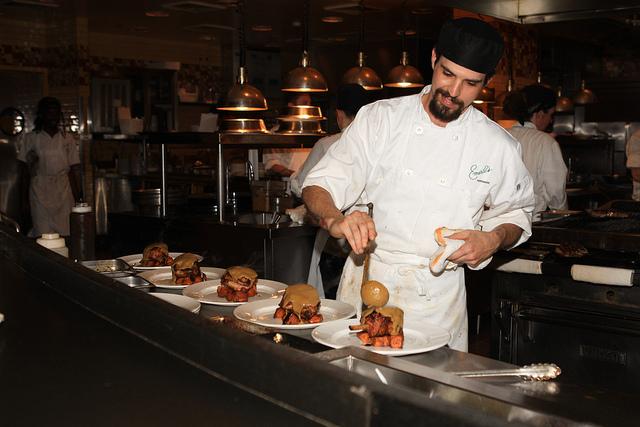What are the people making?
Be succinct. Dinner. What is this man preparing with the ladle?
Be succinct. Gravy. Is every cook wearing a hat?
Give a very brief answer. Yes. What types of foods are being sold?
Give a very brief answer. Desserts. Who do the work for?
Write a very short answer. Restaurant. Do the uniforms look clean?
Short answer required. Yes. Are there tongs in the photo?
Answer briefly. Yes. What kind of food is sold at this restaurant?
Give a very brief answer. American. 